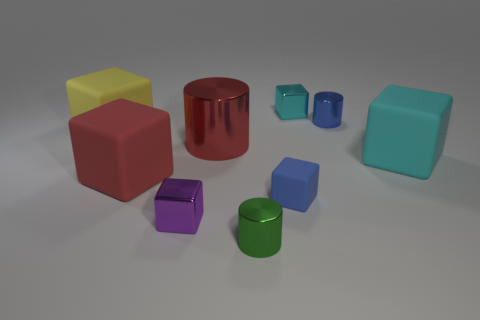Subtract 2 blocks. How many blocks are left? 4 Subtract all cyan blocks. How many blocks are left? 4 Subtract all red blocks. How many blocks are left? 5 Subtract all gray blocks. Subtract all gray spheres. How many blocks are left? 6 Add 1 purple things. How many objects exist? 10 Subtract all blocks. How many objects are left? 3 Add 9 blue metal cylinders. How many blue metal cylinders are left? 10 Add 5 tiny blue shiny objects. How many tiny blue shiny objects exist? 6 Subtract 0 green blocks. How many objects are left? 9 Subtract all large rubber cylinders. Subtract all small purple cubes. How many objects are left? 8 